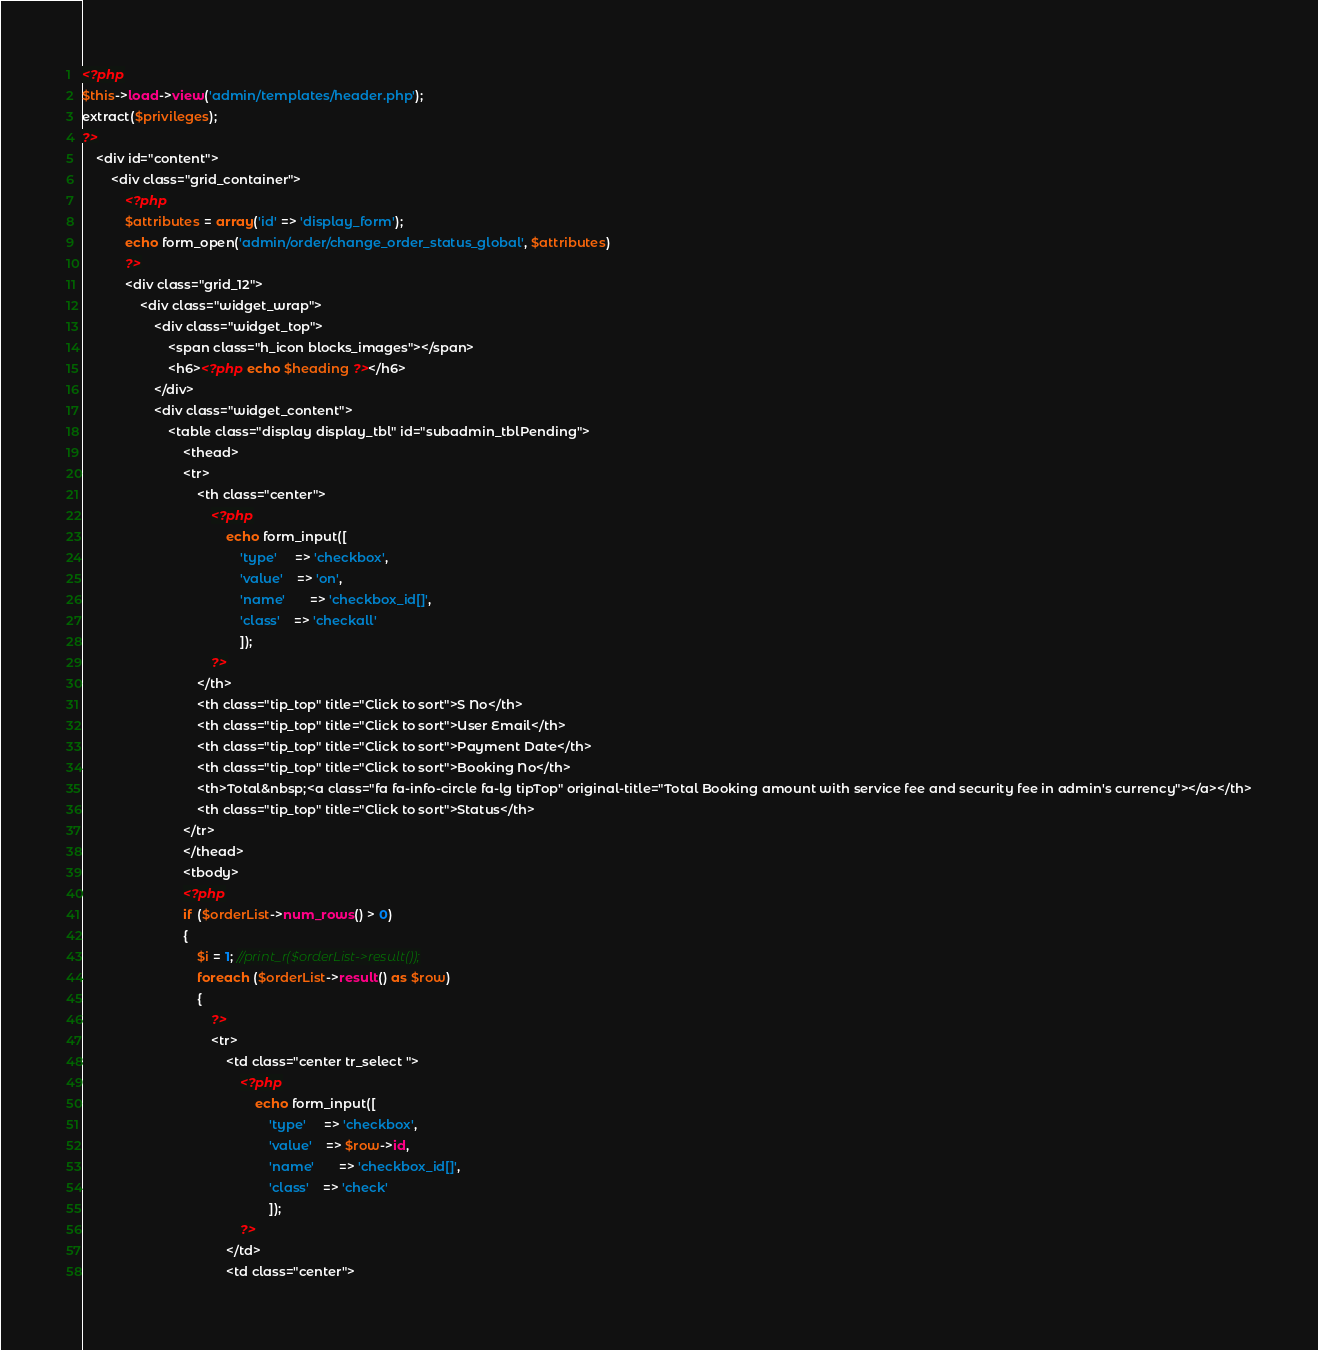<code> <loc_0><loc_0><loc_500><loc_500><_PHP_><?php
$this->load->view('admin/templates/header.php');
extract($privileges);
?>
	<div id="content">
		<div class="grid_container">
			<?php
			$attributes = array('id' => 'display_form');
			echo form_open('admin/order/change_order_status_global', $attributes)
			?>
			<div class="grid_12">
				<div class="widget_wrap">
					<div class="widget_top">
						<span class="h_icon blocks_images"></span>
						<h6><?php echo $heading ?></h6>
					</div>
					<div class="widget_content">
						<table class="display display_tbl" id="subadmin_tblPending">
							<thead>
							<tr>
								<th class="center">
									<?php
										echo form_input([
											'type'     => 'checkbox',
									        'value'    => 'on',
									        'name' 	   => 'checkbox_id[]',
									        'class'    => 'checkall'
									        ]);	
									?>
								</th>
								<th class="tip_top" title="Click to sort">S No</th>
								<th class="tip_top" title="Click to sort">User Email</th>
								<th class="tip_top" title="Click to sort">Payment Date</th>
								<th class="tip_top" title="Click to sort">Booking No</th>
								<th>Total&nbsp;<a class="fa fa-info-circle fa-lg tipTop" original-title="Total Booking amount with service fee and security fee in admin's currency"></a></th>
								<th class="tip_top" title="Click to sort">Status</th>
							</tr>
							</thead>
							<tbody>
							<?php
							if ($orderList->num_rows() > 0) 
							{
								$i = 1; //print_r($orderList->result());
								foreach ($orderList->result() as $row) 
								{
									?>
									<tr>
										<td class="center tr_select ">
											<?php
												echo form_input([
													'type'     => 'checkbox',
											        'value'    => $row->id,
											        'name' 	   => 'checkbox_id[]',
											        'class'    => 'check'
											        ]);	
											?>
										</td>
										<td class="center"></code> 